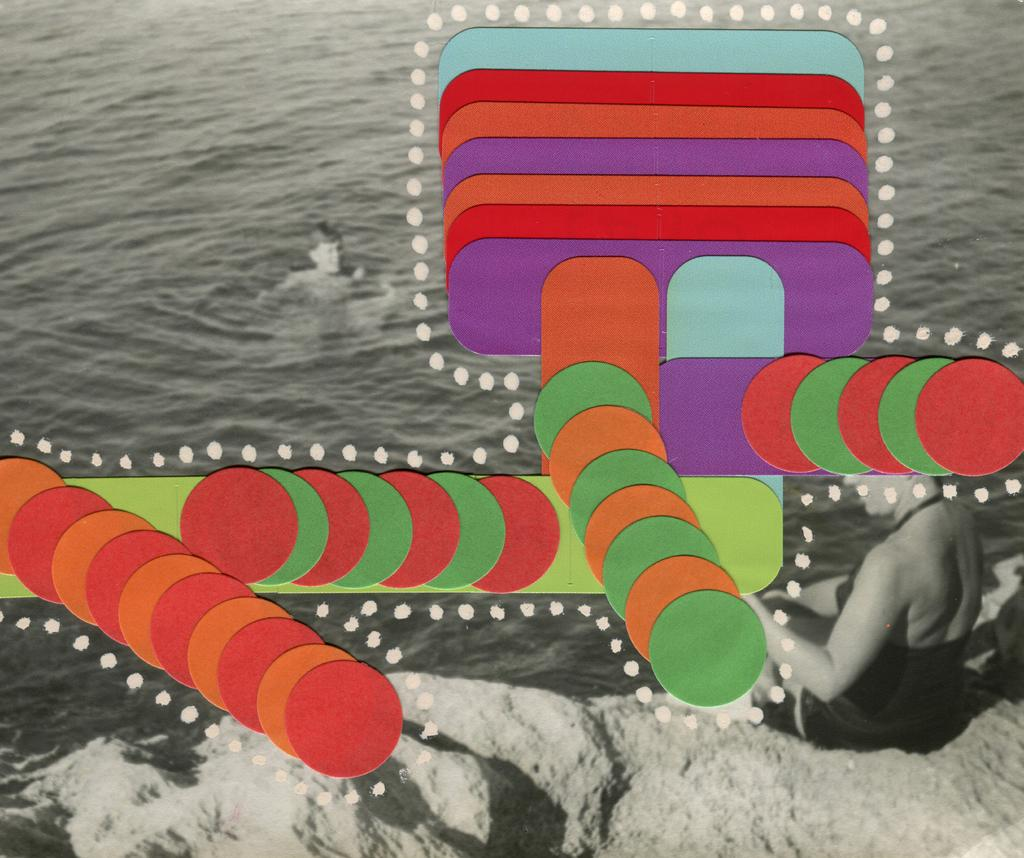What type of image is being described? The image is an edited picture. What is the person in the image doing? There is a person standing in the water. What is the woman in the image doing? There is a woman sitting on a rock. What is at the bottom of the image? There is water at the bottom of the image. What type of cap is the woman wearing in the image? There is no cap visible in the image; the woman is sitting on a rock without any headwear. What degree does the person standing in the water have? There is no information about the person's degree in the image; it only shows them standing in the water. 